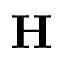Convert formula to latex. <formula><loc_0><loc_0><loc_500><loc_500>H</formula> 